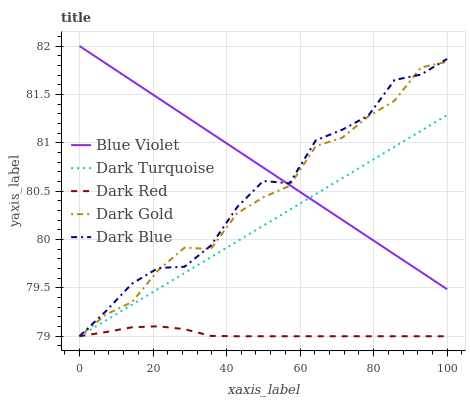Does Dark Gold have the minimum area under the curve?
Answer yes or no. No. Does Dark Gold have the maximum area under the curve?
Answer yes or no. No. Is Dark Gold the smoothest?
Answer yes or no. No. Is Dark Gold the roughest?
Answer yes or no. No. Does Blue Violet have the lowest value?
Answer yes or no. No. Does Dark Gold have the highest value?
Answer yes or no. No. Is Dark Red less than Blue Violet?
Answer yes or no. Yes. Is Blue Violet greater than Dark Red?
Answer yes or no. Yes. Does Dark Red intersect Blue Violet?
Answer yes or no. No. 